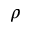Convert formula to latex. <formula><loc_0><loc_0><loc_500><loc_500>\rho</formula> 